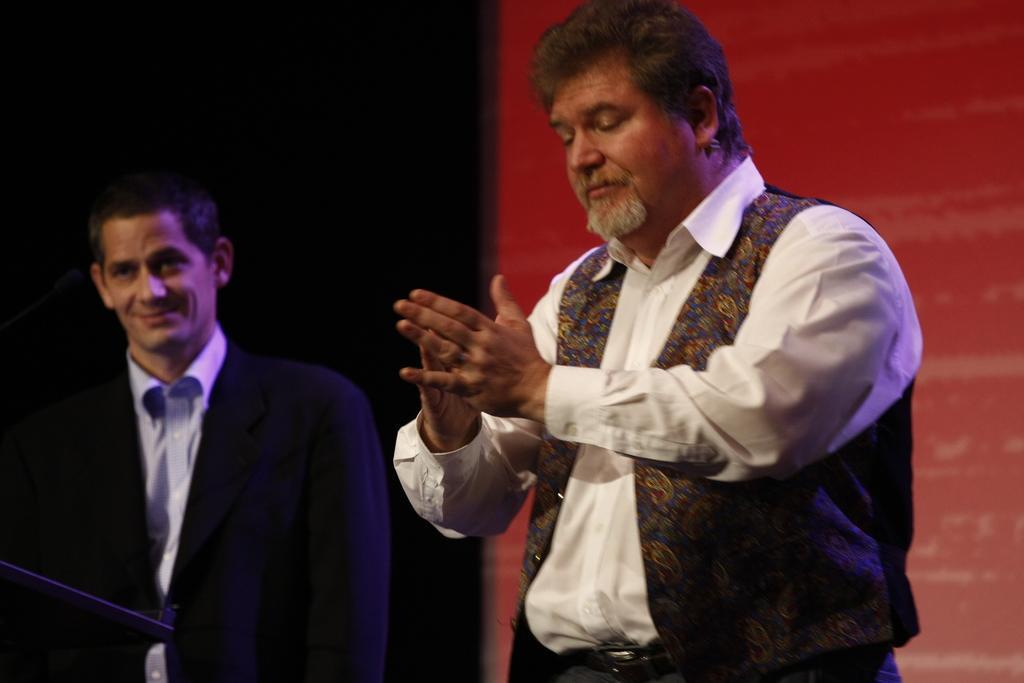Can you describe this image briefly? In this image we can see two men standing. On the backside we can see a wall. 